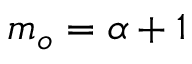Convert formula to latex. <formula><loc_0><loc_0><loc_500><loc_500>m _ { o } = \alpha + 1</formula> 